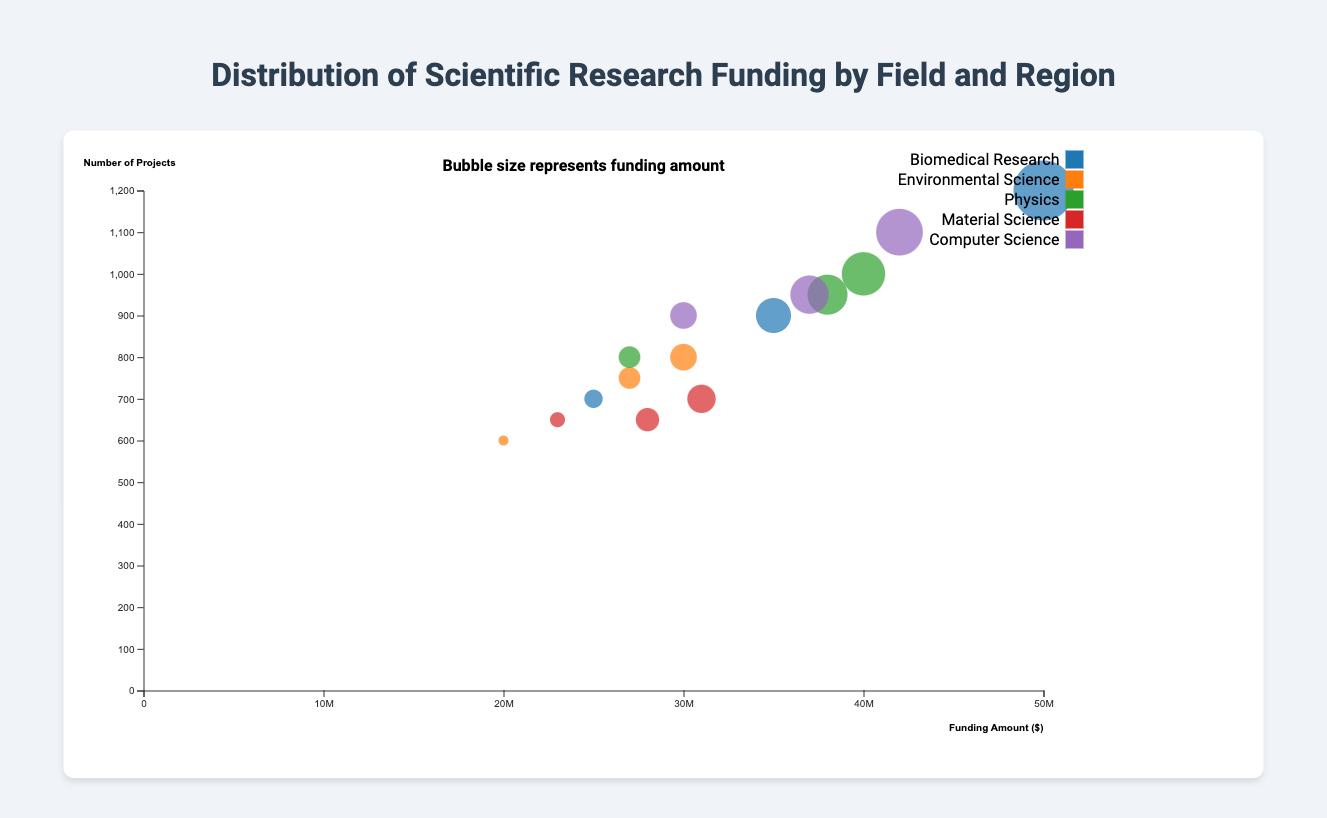What's the title of the chart? The title of the chart is displayed at the top, indicating the main subject of the visual representation.
Answer: Distribution of Scientific Research Funding by Field and Region What are the axes labels for the chart? The x-axis at the bottom of the chart is labeled with "Funding Amount ($)" indicating the funding amount in dollars, and the y-axis on the left side of the chart is labeled with "Number of Projects" indicating the number of projects.
Answer: Funding Amount ($), Number of Projects Which scientific field has the largest funding amount in North America? By examining the size of the bubbles corresponding to North America, the largest bubble represents Biomedical Research, indicating it has the largest funding amount.
Answer: Biomedical Research How many more projects in Europe does Biomedical Research have compared to Environmental Science? The number of projects for Biomedical Research in Europe is 900, and for Environmental Science in Europe, it is 750. The difference is calculated by subtracting 750 from 900.
Answer: 150 Which region has the lowest funding amount for Computer Science? By comparing the sizes of the bubbles representing Computer Science across different regions, the smallest bubble corresponds to Asia, indicating it has the lowest funding amount.
Answer: Asia Which region has the highest number of projects for Physics? Looking at the Physics bubbles and their positions on the y-axis, North America has the bubble positioned highest, indicating it has the highest number of projects.
Answer: North America In which field and region is the bubble with the smallest size? The smallest bubble, representing the lowest funding amount, is found for Material Science in Asia.
Answer: Material Science in Asia What is the total funding amount for Environmental Science across all regions? Adding the funding amounts for Environmental Science in the three regions: North America (30000000), Europe (27000000), and Asia (20000000) results in the total funding.
Answer: 77000000 Which field and region combination has approximately the same number of projects but different funding amounts, and what are those funding amounts? Both Biomedical Research in Asia and Material Science in Asia have approximately the same number of projects (700 and 650, respectively). Their funding amounts are 25000000 and 23000000, respectively.
Answer: Biomedical Research (25000000), Material Science (23000000) What is the largest funding amount across all fields and regions? By examining the size of the bubbles, the largest bubble represents Biomedical Research in North America, indicating it has the largest funding amount.
Answer: 50000000 